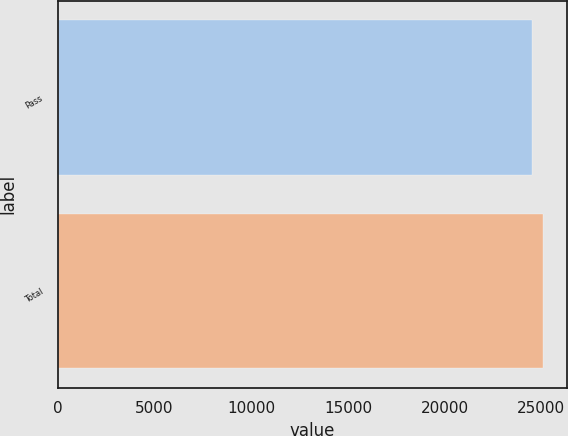Convert chart to OTSL. <chart><loc_0><loc_0><loc_500><loc_500><bar_chart><fcel>Pass<fcel>Total<nl><fcel>24505<fcel>25078<nl></chart> 